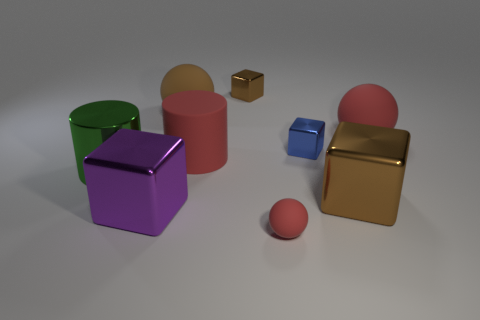Add 1 small green blocks. How many objects exist? 10 Subtract all balls. How many objects are left? 6 Subtract all purple blocks. How many blocks are left? 3 Subtract 1 cylinders. How many cylinders are left? 1 Subtract all rubber objects. Subtract all tiny objects. How many objects are left? 2 Add 3 brown balls. How many brown balls are left? 4 Add 6 red balls. How many red balls exist? 8 Subtract all large brown cubes. How many cubes are left? 3 Subtract 0 brown cylinders. How many objects are left? 9 Subtract all green cylinders. Subtract all red balls. How many cylinders are left? 1 